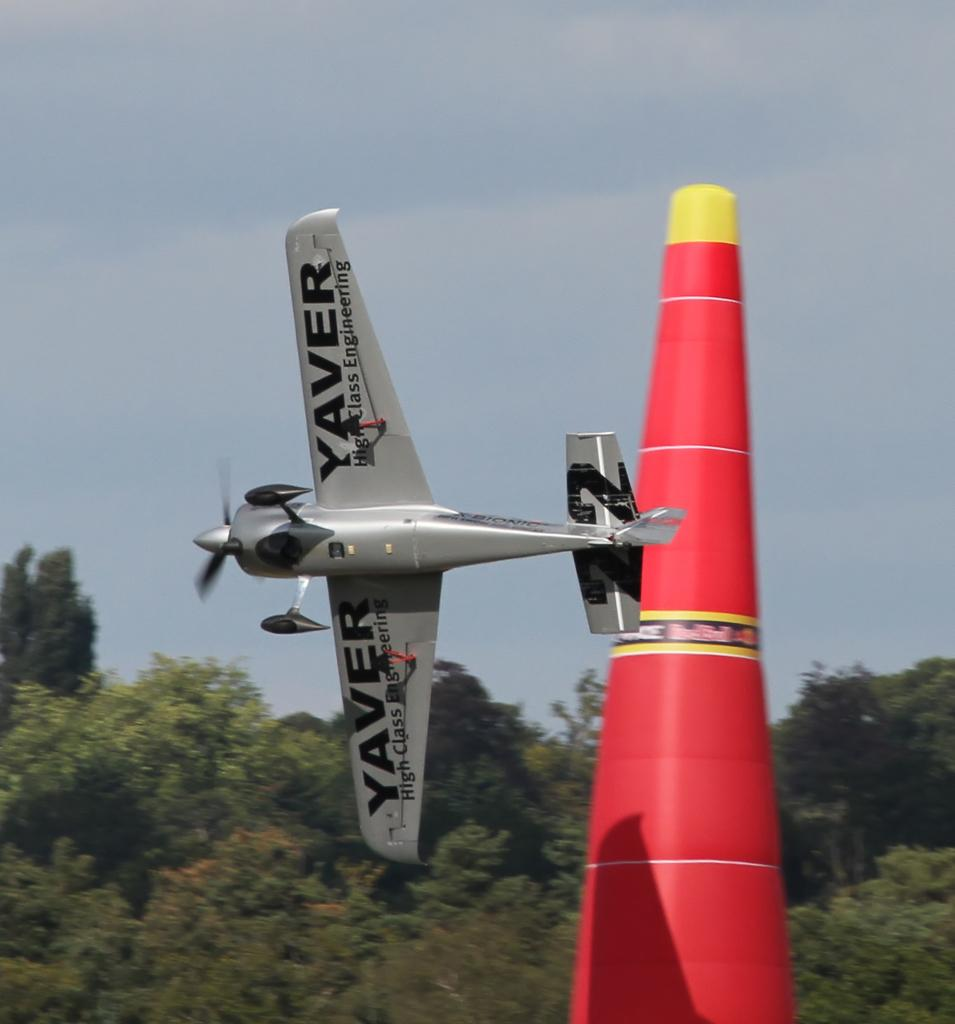Provide a one-sentence caption for the provided image. a Yaver plane is cutting hard around a red cone. 